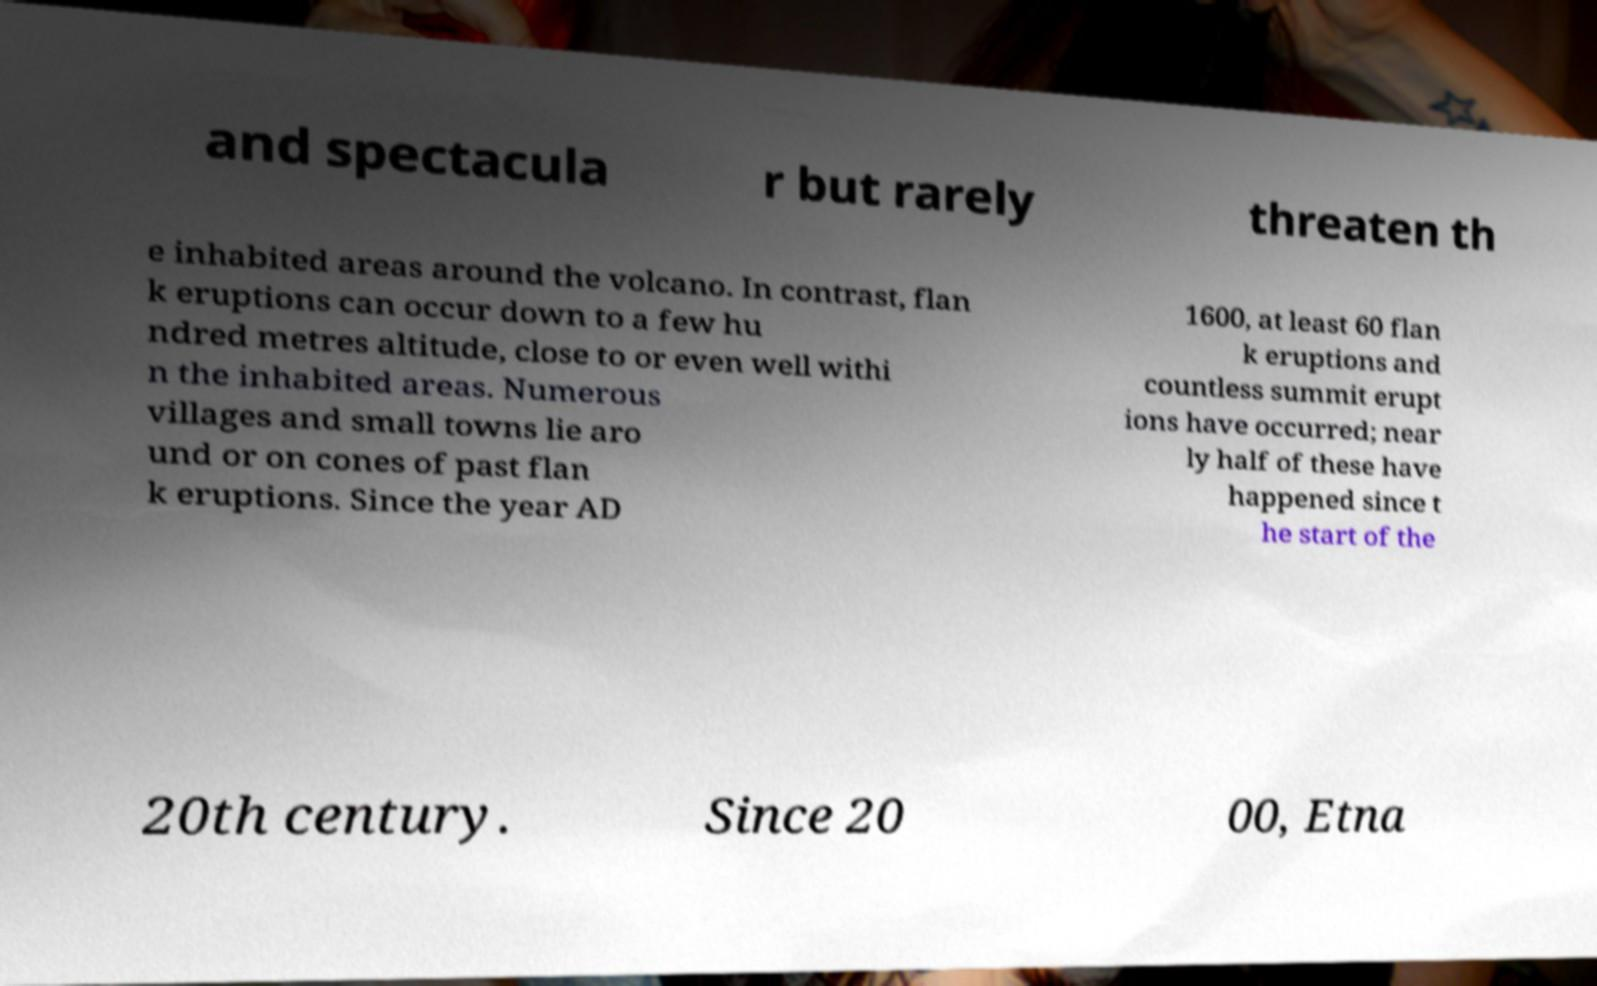What messages or text are displayed in this image? I need them in a readable, typed format. and spectacula r but rarely threaten th e inhabited areas around the volcano. In contrast, flan k eruptions can occur down to a few hu ndred metres altitude, close to or even well withi n the inhabited areas. Numerous villages and small towns lie aro und or on cones of past flan k eruptions. Since the year AD 1600, at least 60 flan k eruptions and countless summit erupt ions have occurred; near ly half of these have happened since t he start of the 20th century. Since 20 00, Etna 